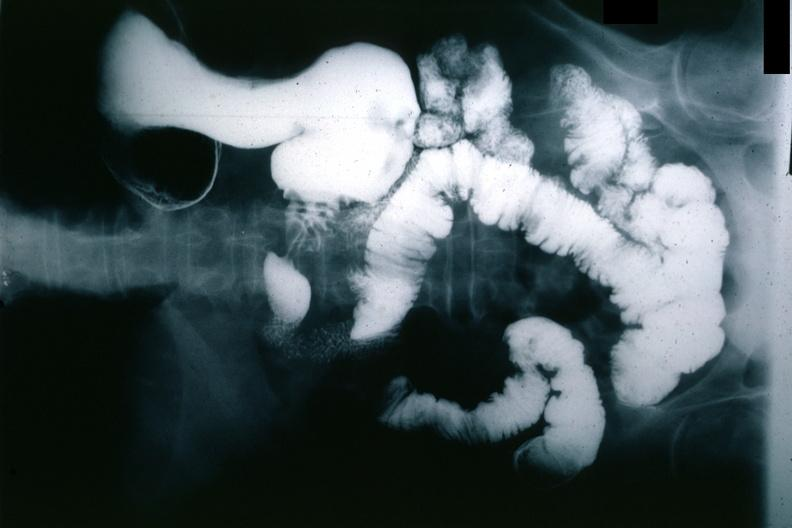s gastrointestinal present?
Answer the question using a single word or phrase. Yes 